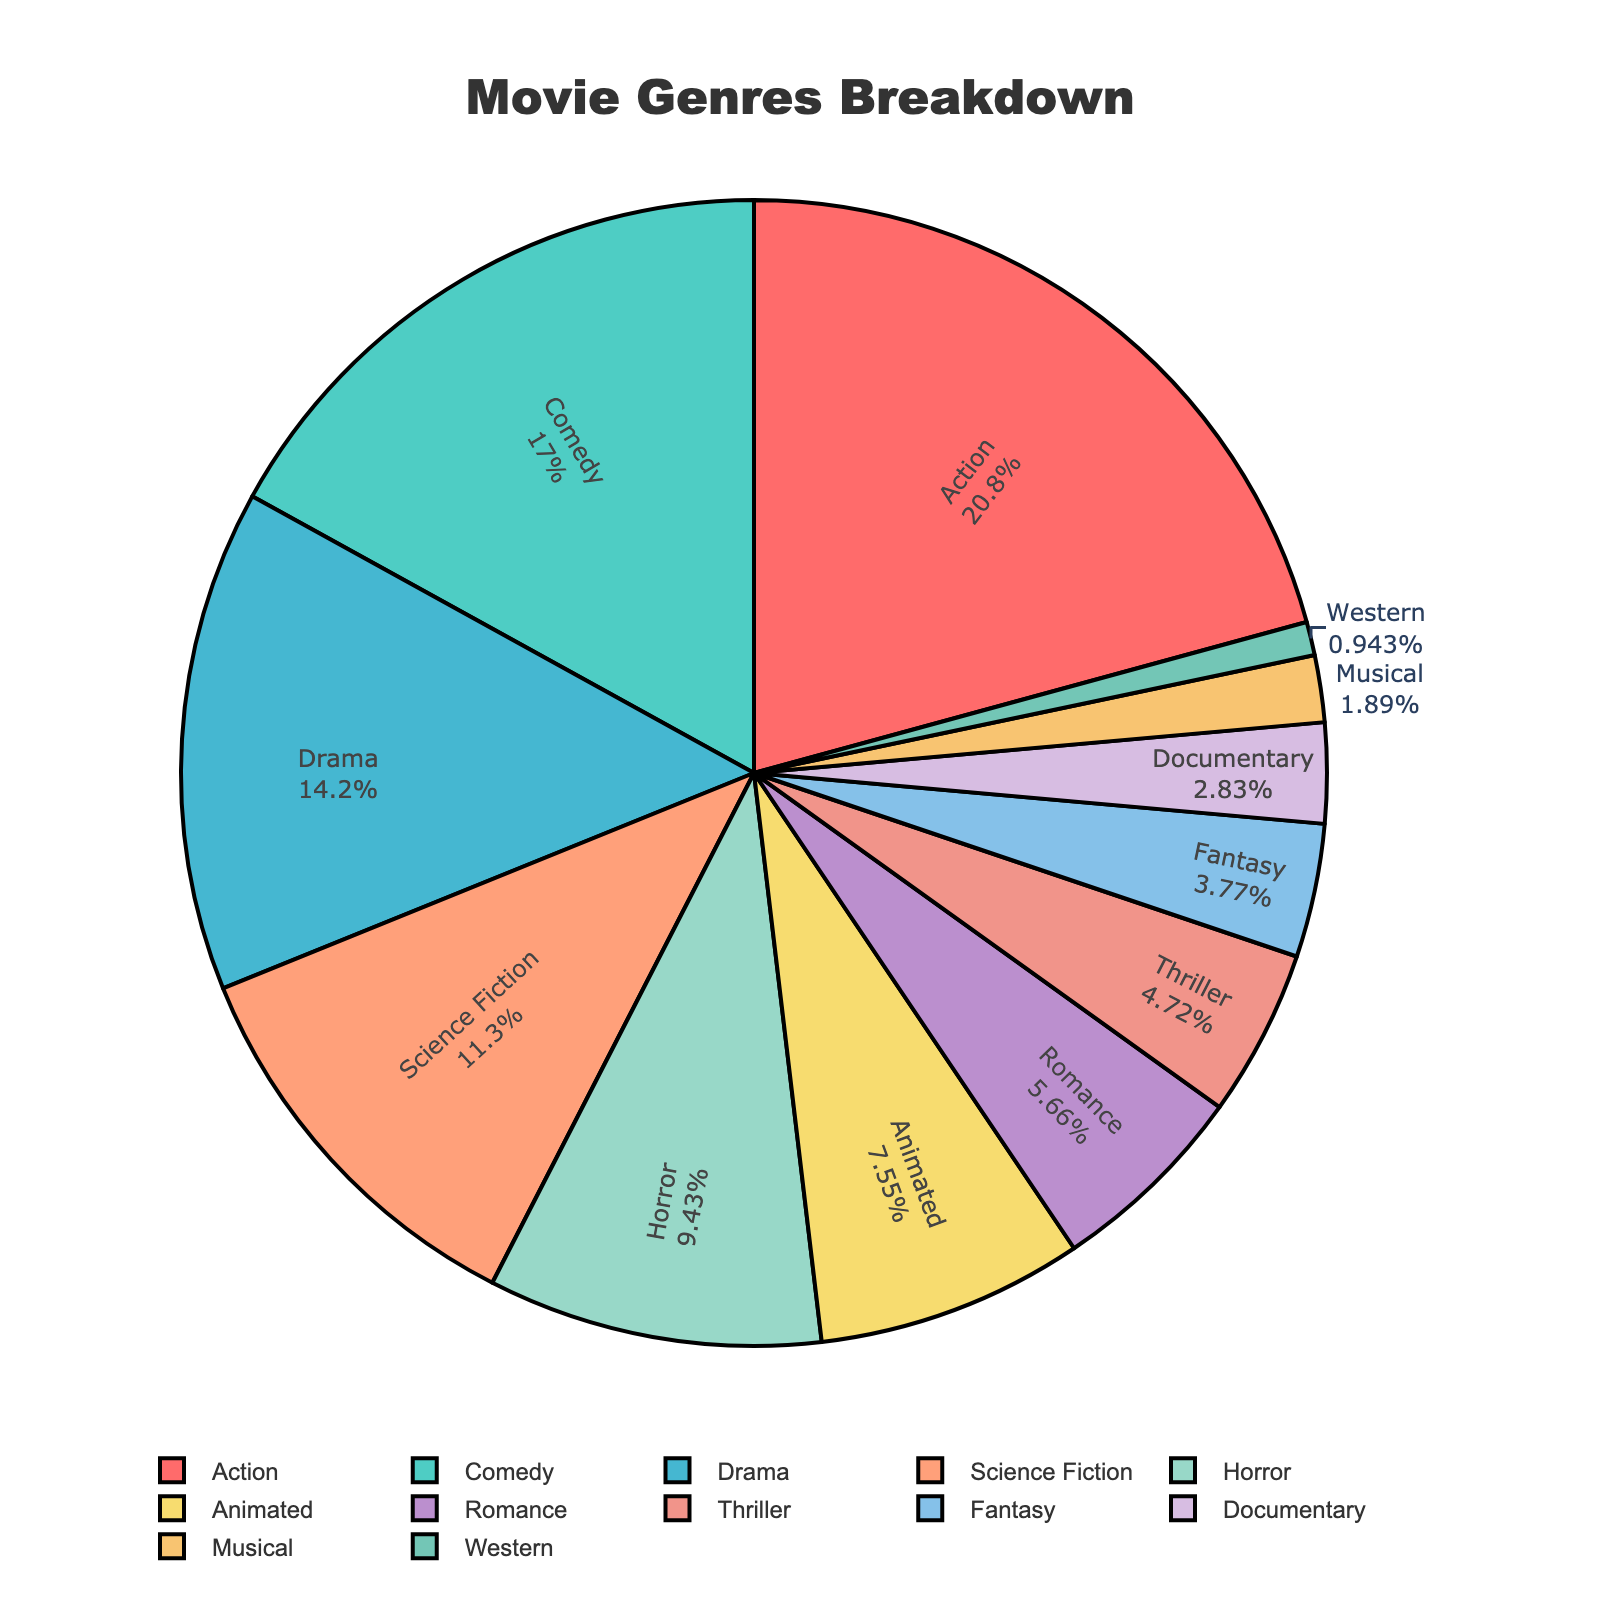What is the most shown genre in the theater over the past year? The most shown genre is the one with the largest percentage in the pie chart. "Action" has the largest slice at 22%.
Answer: Action Which genres together account for more than 50% of the movies shown? Sum the percentages of the largest slices until the sum exceeds 50%. Adding Action (22%), Comedy (18%), and Drama (15%) gives 55%, which is more than 50%.
Answer: Action, Comedy, Drama What is the difference in percentage between the Action and Documentary genres? Subtract the percentage of Documentary from Action. Action is 22% and Documentary is 3%, so the difference is 22% - 3% = 19%.
Answer: 19% Are there more Thriller or Science Fiction movies shown? Compare the sizes of the pie chart slices for Thriller and Science Fiction. Science Fiction has 12% while Thriller has 5%, so Science Fiction is shown more.
Answer: Science Fiction How many genres make up less than 5% of the total shown movies? Count the slices with percentages less than 5%. Fantasy, Documentary, Musical, and Western are 4 genres each with less than 5%.
Answer: 4 Which genre has the smallest percentage of movies shown? Identify the smallest slice in the pie chart. Western has the smallest slice at 1%.
Answer: Western What is the total percentage of Horror and Romance movies shown? Add the percentages of Horror and Romance. Horror is 10% and Romance is 6%, so the total is 10% + 6% = 16%.
Answer: 16% Which genre has the largest visual slice after Action and Comedy? After Action (22%) and Comedy (18%), the next largest slice is Drama at 15%.
Answer: Drama What is the average percentage of the top four genres? Calculate the average of the top four percentages (Action, Comedy, Drama, Science Fiction). (22% + 18% + 15% + 12%) / 4 = 16.75%.
Answer: 16.75% What is the combined percentage of all genres that have an equal or lesser percentage than Musical? Combine all percentages of genres with 2% or less. Musical and Western have 2% and 1%, so the total is 2% + 1% = 3%.
Answer: 3% 